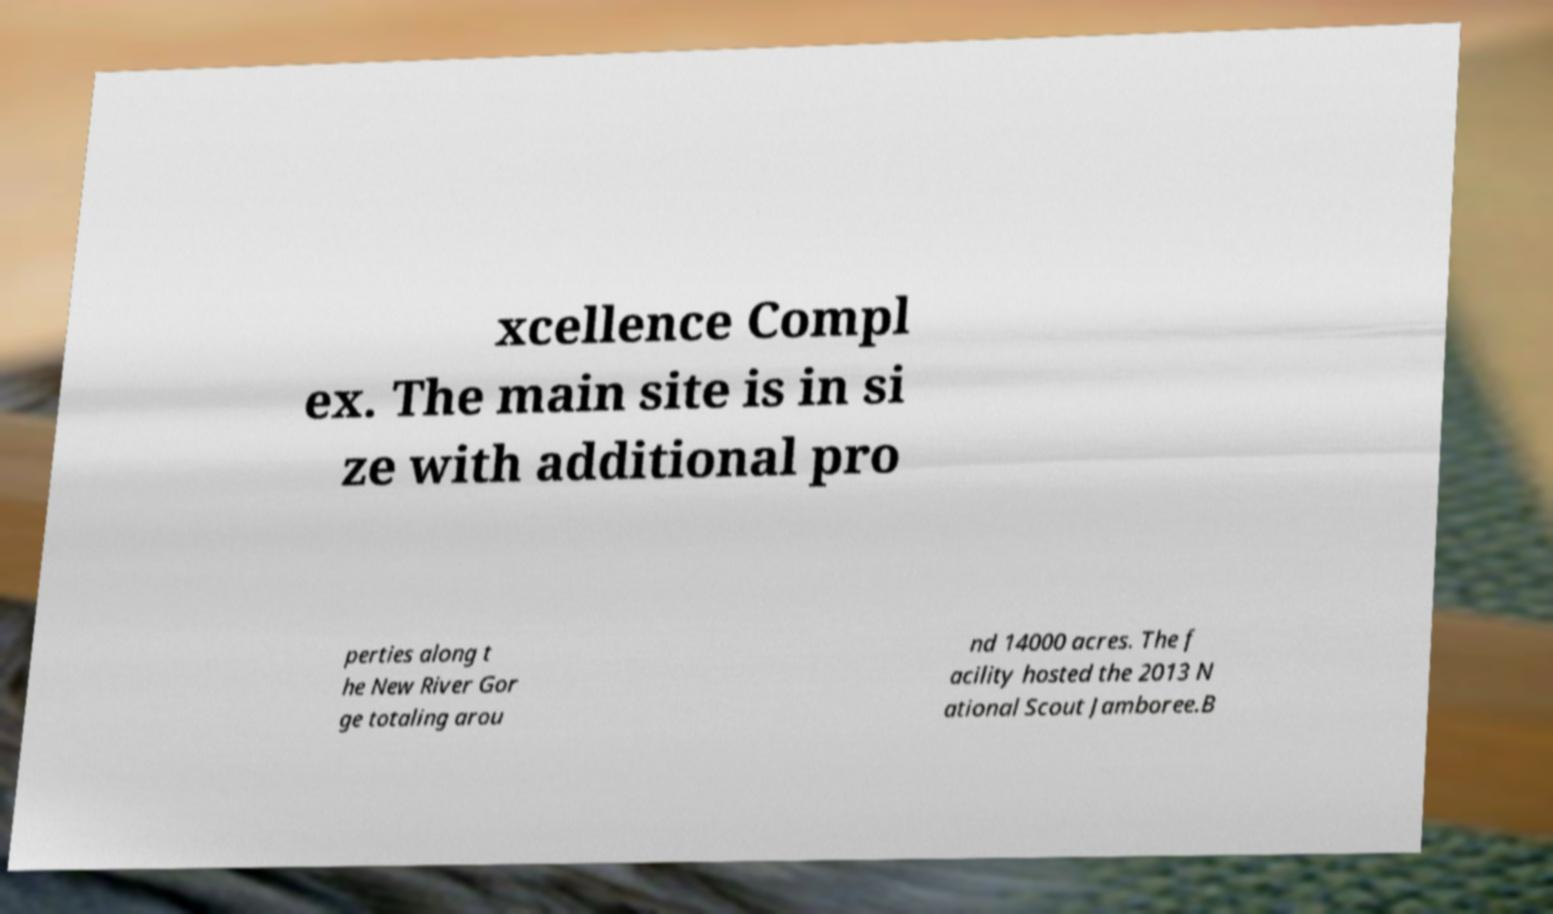Can you read and provide the text displayed in the image?This photo seems to have some interesting text. Can you extract and type it out for me? xcellence Compl ex. The main site is in si ze with additional pro perties along t he New River Gor ge totaling arou nd 14000 acres. The f acility hosted the 2013 N ational Scout Jamboree.B 